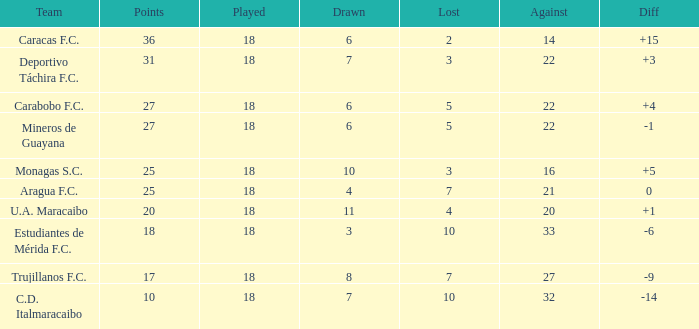What is the combined points of all teams that had against scores under 14? None. 